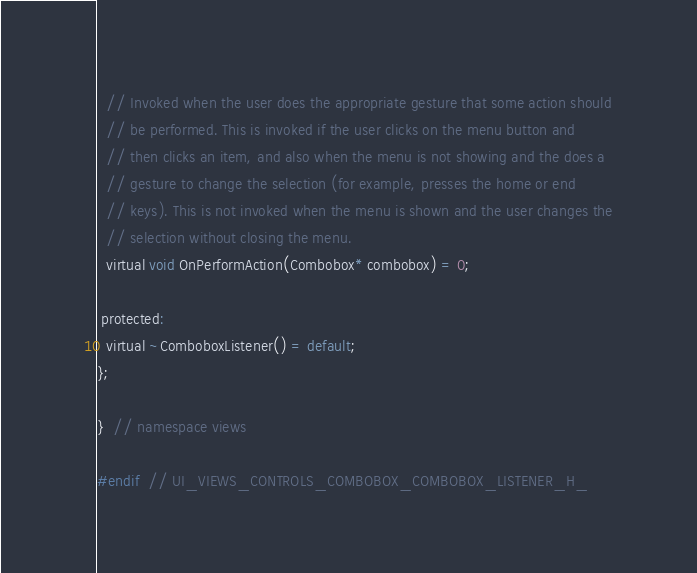<code> <loc_0><loc_0><loc_500><loc_500><_C_>  // Invoked when the user does the appropriate gesture that some action should
  // be performed. This is invoked if the user clicks on the menu button and
  // then clicks an item, and also when the menu is not showing and the does a
  // gesture to change the selection (for example, presses the home or end
  // keys). This is not invoked when the menu is shown and the user changes the
  // selection without closing the menu.
  virtual void OnPerformAction(Combobox* combobox) = 0;

 protected:
  virtual ~ComboboxListener() = default;
};

}  // namespace views

#endif  // UI_VIEWS_CONTROLS_COMBOBOX_COMBOBOX_LISTENER_H_
</code> 